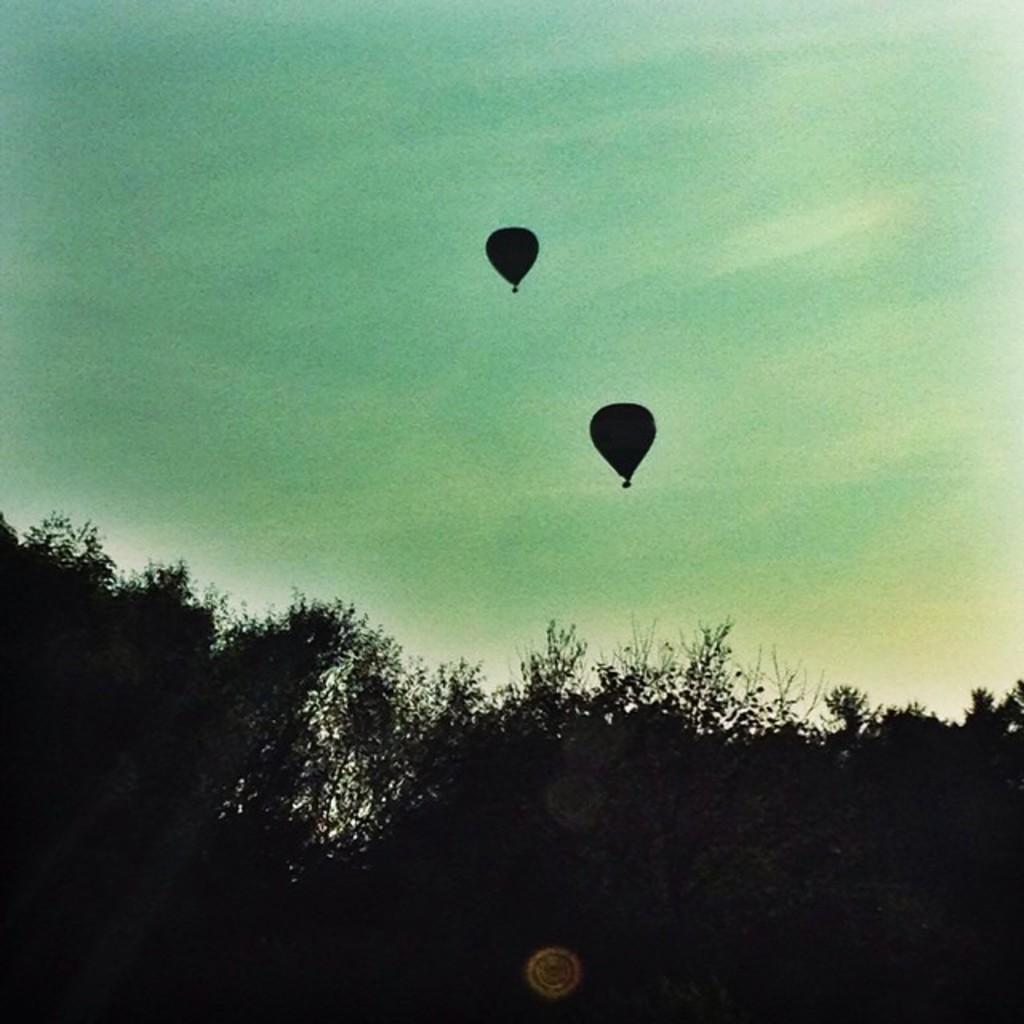Please provide a concise description of this image. In this image there are two hot air balloons and trees and a sky. 